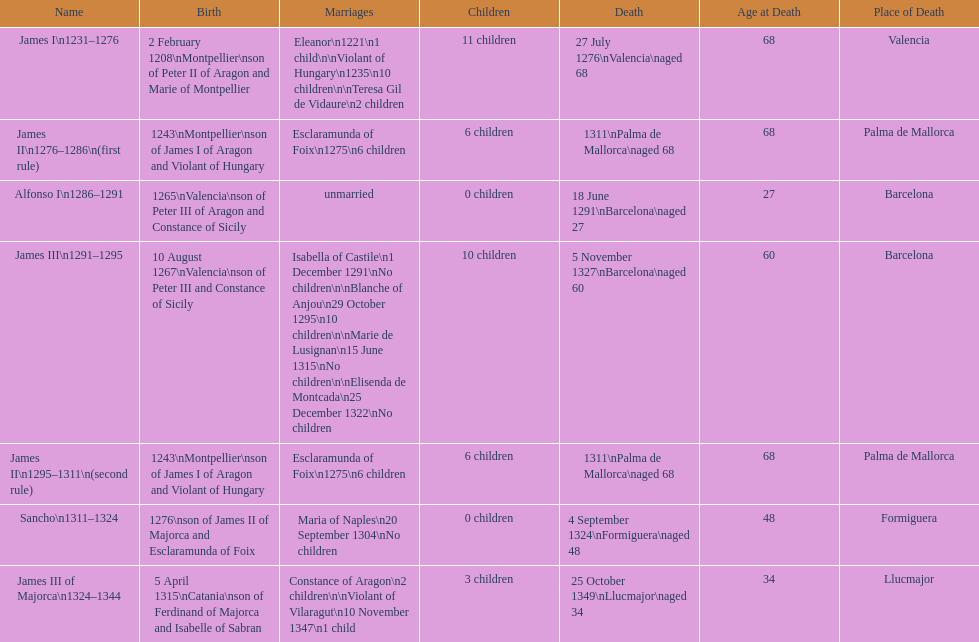Which two monarchs had no children? Alfonso I, Sancho. 